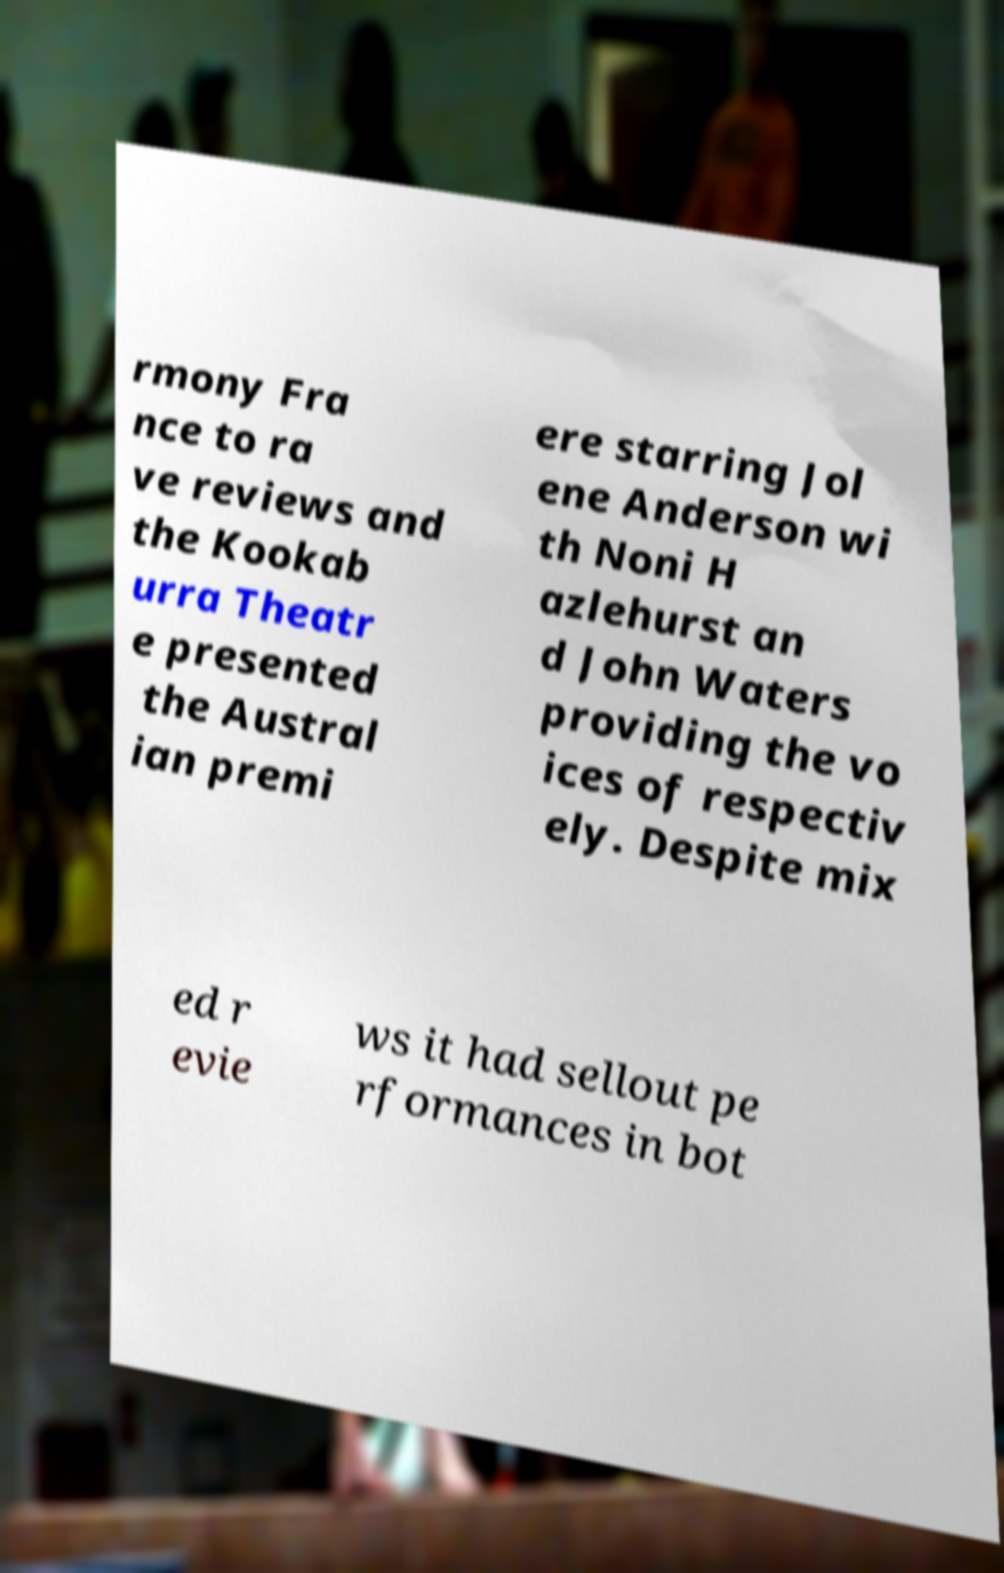I need the written content from this picture converted into text. Can you do that? rmony Fra nce to ra ve reviews and the Kookab urra Theatr e presented the Austral ian premi ere starring Jol ene Anderson wi th Noni H azlehurst an d John Waters providing the vo ices of respectiv ely. Despite mix ed r evie ws it had sellout pe rformances in bot 